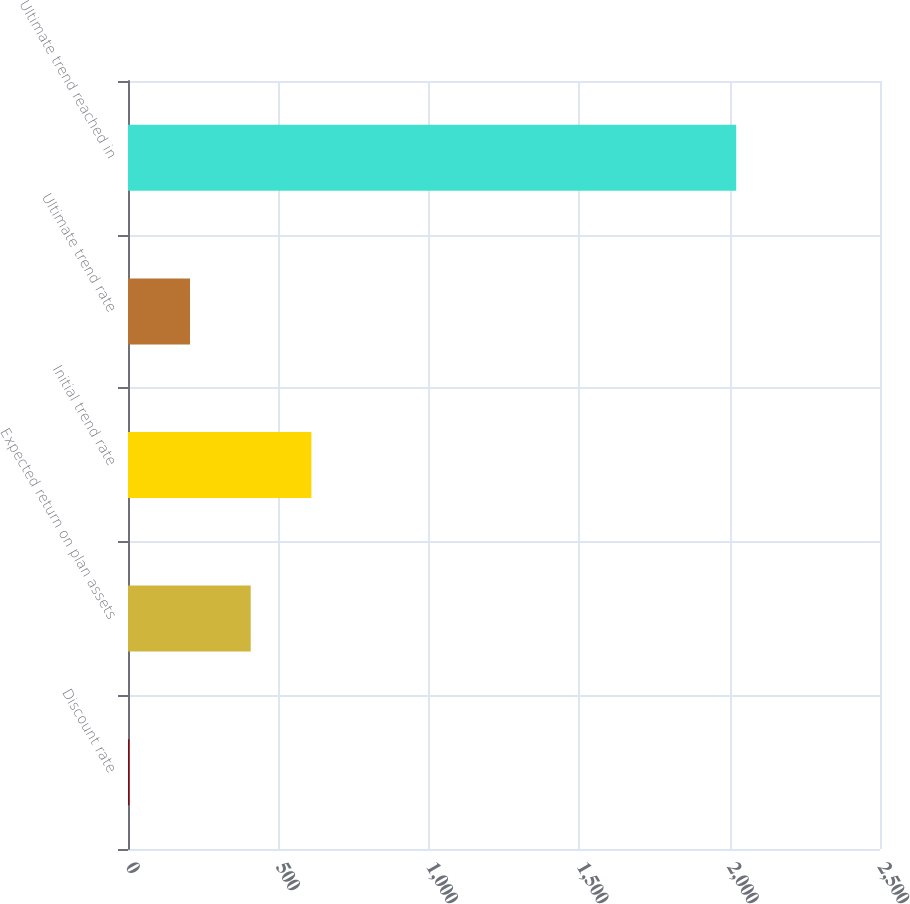<chart> <loc_0><loc_0><loc_500><loc_500><bar_chart><fcel>Discount rate<fcel>Expected return on plan assets<fcel>Initial trend rate<fcel>Ultimate trend rate<fcel>Ultimate trend reached in<nl><fcel>4.38<fcel>407.9<fcel>609.66<fcel>206.14<fcel>2022<nl></chart> 